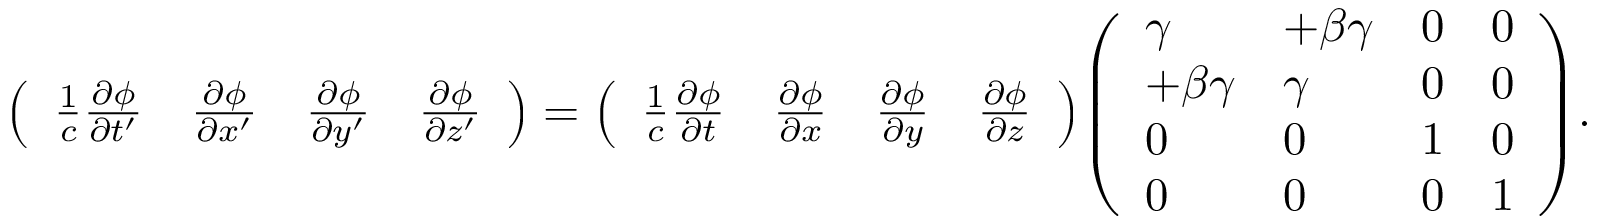<formula> <loc_0><loc_0><loc_500><loc_500>{ \left ( \begin{array} { l l l l } { { \frac { 1 } { c } } { \frac { \partial \phi } { \partial t ^ { \prime } } } } & { { \frac { \partial \phi } { \partial x ^ { \prime } } } } & { { \frac { \partial \phi } { \partial y ^ { \prime } } } } & { { \frac { \partial \phi } { \partial z ^ { \prime } } } } \end{array} \right ) } = { \left ( \begin{array} { l l l l } { { \frac { 1 } { c } } { \frac { \partial \phi } { \partial t } } } & { { \frac { \partial \phi } { \partial x } } } & { { \frac { \partial \phi } { \partial y } } } & { { \frac { \partial \phi } { \partial z } } } \end{array} \right ) } { \left ( \begin{array} { l l l l } { \gamma } & { + \beta \gamma } & { 0 } & { 0 } \\ { + \beta \gamma } & { \gamma } & { 0 } & { 0 } \\ { 0 } & { 0 } & { 1 } & { 0 } \\ { 0 } & { 0 } & { 0 } & { 1 } \end{array} \right ) } .</formula> 